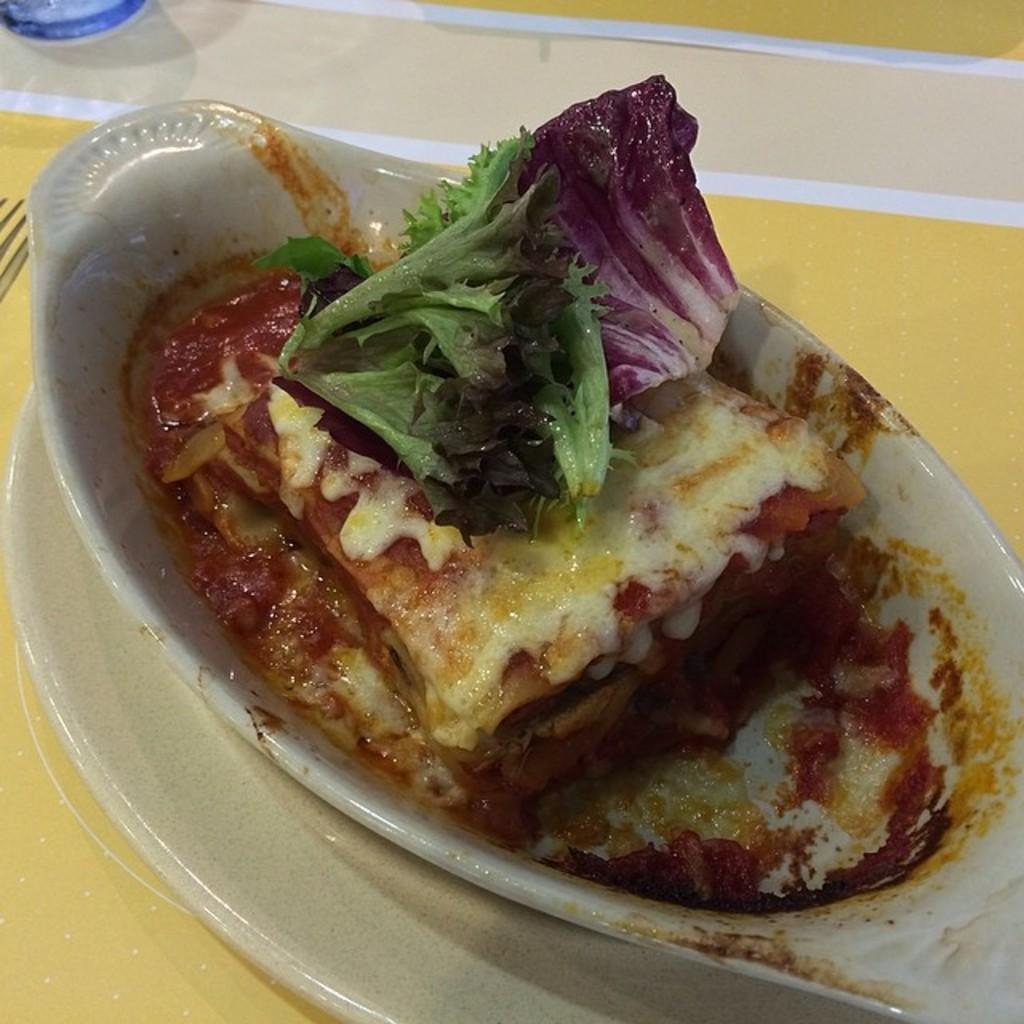What is in the bowl that is visible in the image? There is food in a bowl in the image. What other dishware is present in the image? There is a plate in the image. What utensil is visible in the image? There is a fork in the image. Where are the bowl, plate, and fork located in the image? The bowl, plate, and fork are placed on a table. How many legs can be seen on the grass in the image? There is no grass present in the image, so it is not possible to see any legs on it. 